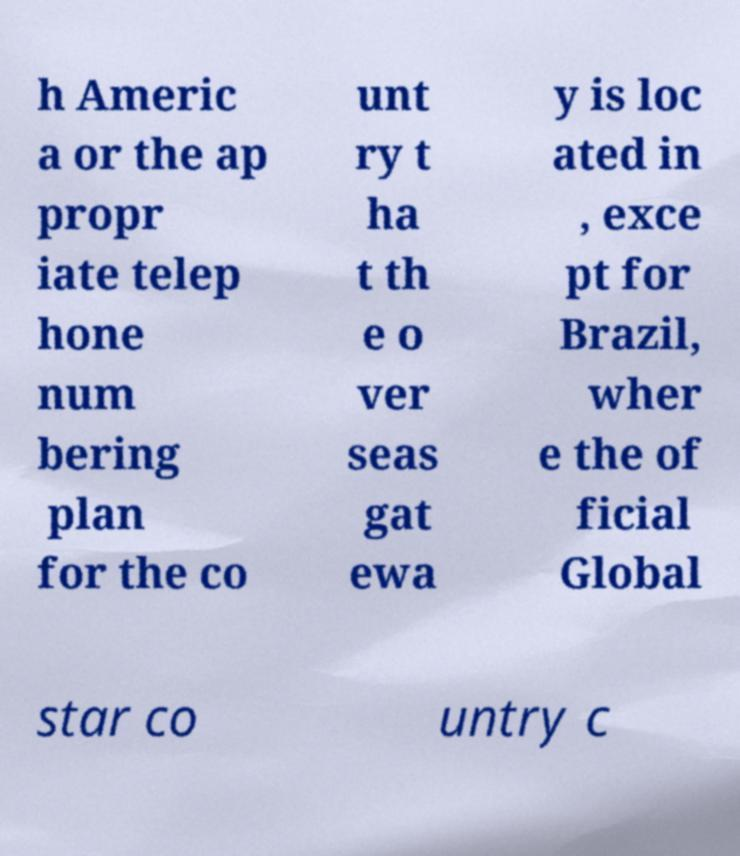Could you extract and type out the text from this image? h Americ a or the ap propr iate telep hone num bering plan for the co unt ry t ha t th e o ver seas gat ewa y is loc ated in , exce pt for Brazil, wher e the of ficial Global star co untry c 